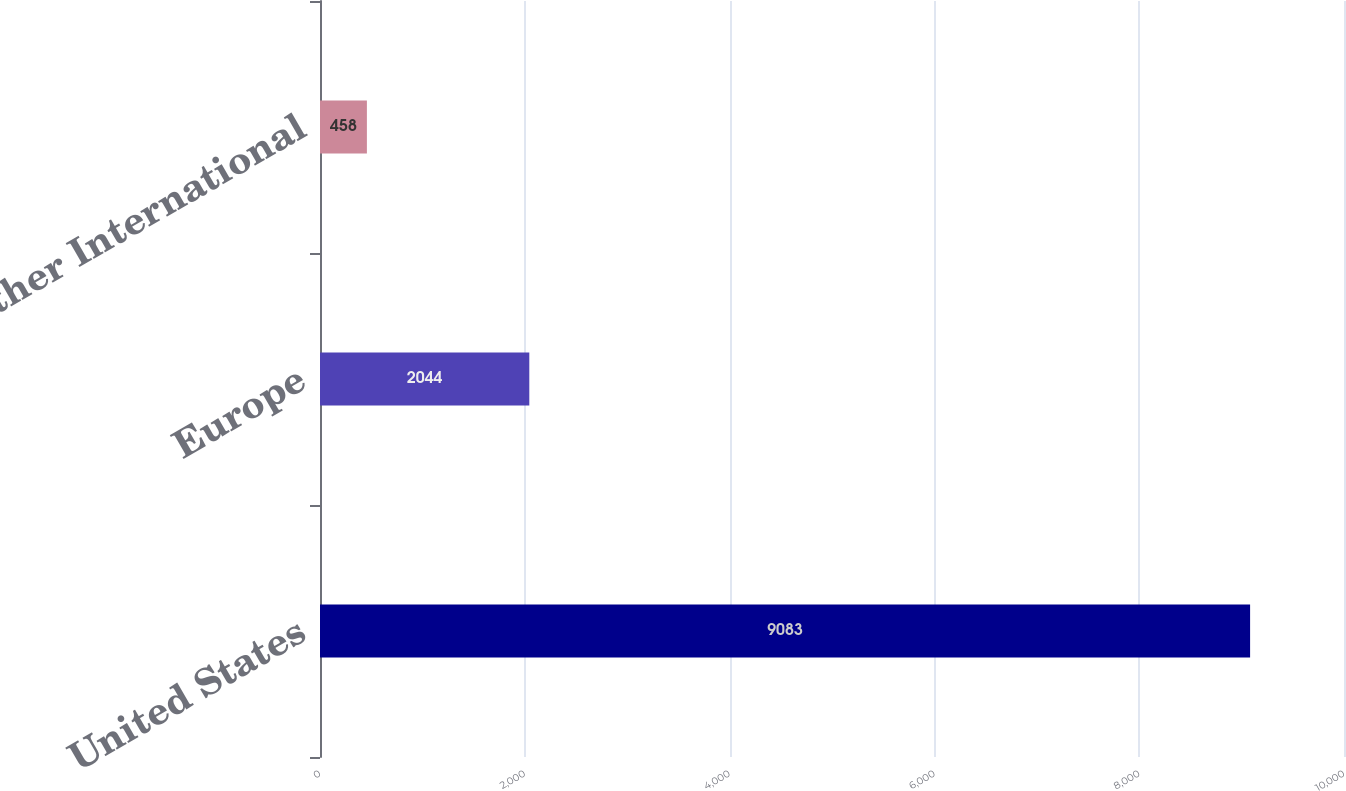Convert chart. <chart><loc_0><loc_0><loc_500><loc_500><bar_chart><fcel>United States<fcel>Europe<fcel>Other International<nl><fcel>9083<fcel>2044<fcel>458<nl></chart> 